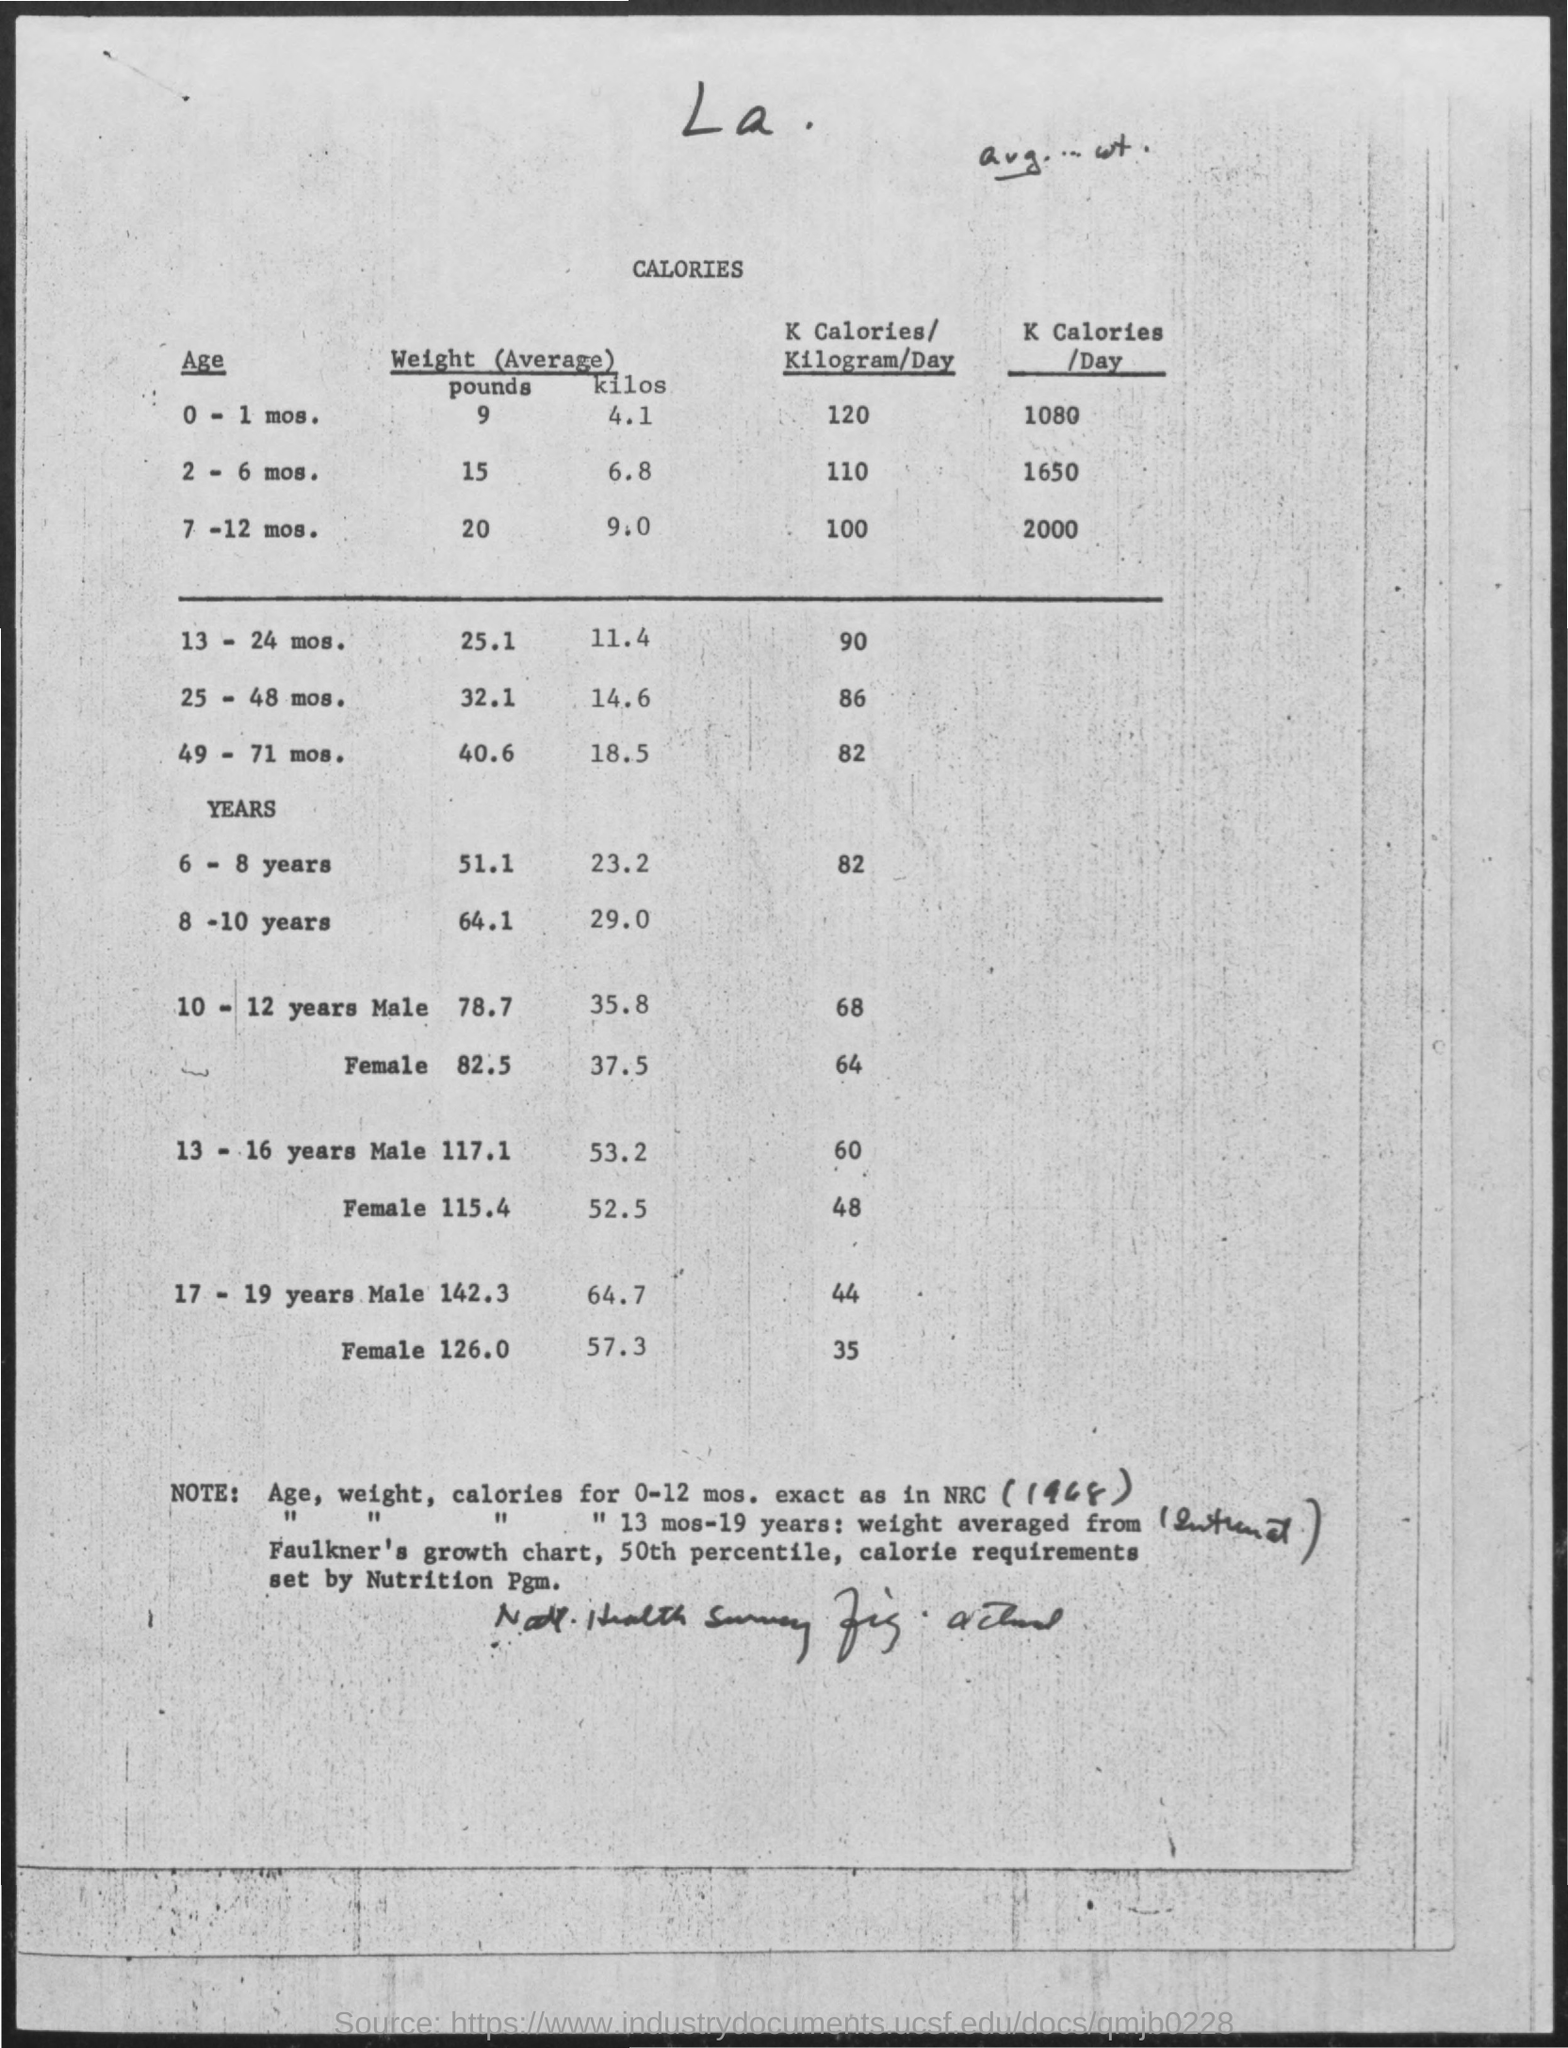What is the average weight in pounds for the age of 0-1 mos. ?
Offer a terse response. 9. What is the average weight in kilos for the age of 2-6 mos. ?
Offer a terse response. 6.8. What is the average weight in pounds for the age of 7-12 mos. ?
Your answer should be compact. 20. What is the average weight in pounds for the age of 13-24 mos. ?
Ensure brevity in your answer.  25 1. What is the average weight in kilos for the age of 25-48 mos.?
Make the answer very short. 14.6. What is the average weight in pounds for the age of 6-8 years?
Provide a short and direct response. 51 1. What is the average weight in pounds for the age of 8-10 years?
Offer a terse response. 64.1. 